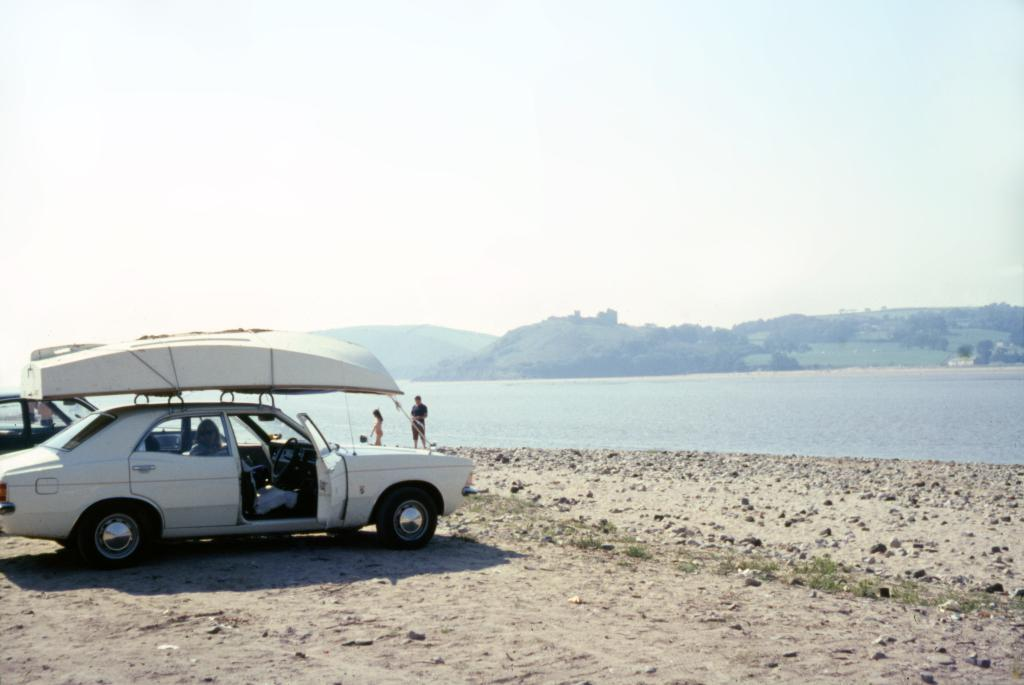What is the main subject of the image? There is a car in the image. What is located above the car in the image? There is a boat above the car in the image. How many people are present in the image? There are two persons in the image. What can be seen in the background of the image? There is water and mountains visible in the background of the image. What type of pot is being used for religious purposes in the image? There is no pot or religious activity present in the image. What is the end result of the journey depicted in the image? The image does not depict a journey or an end result; it simply shows a car and a boat. 